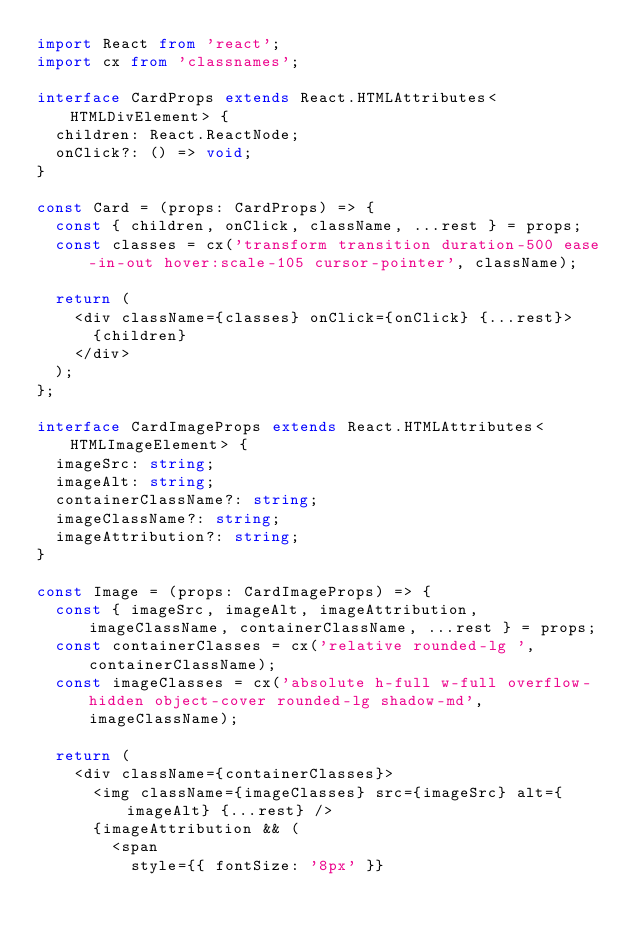<code> <loc_0><loc_0><loc_500><loc_500><_TypeScript_>import React from 'react';
import cx from 'classnames';

interface CardProps extends React.HTMLAttributes<HTMLDivElement> {
  children: React.ReactNode;
  onClick?: () => void;
}

const Card = (props: CardProps) => {
  const { children, onClick, className, ...rest } = props;
  const classes = cx('transform transition duration-500 ease-in-out hover:scale-105 cursor-pointer', className);

  return (
    <div className={classes} onClick={onClick} {...rest}>
      {children}
    </div>
  );
};

interface CardImageProps extends React.HTMLAttributes<HTMLImageElement> {
  imageSrc: string;
  imageAlt: string;
  containerClassName?: string;
  imageClassName?: string;
  imageAttribution?: string;
}

const Image = (props: CardImageProps) => {
  const { imageSrc, imageAlt, imageAttribution, imageClassName, containerClassName, ...rest } = props;
  const containerClasses = cx('relative rounded-lg ', containerClassName);
  const imageClasses = cx('absolute h-full w-full overflow-hidden object-cover rounded-lg shadow-md', imageClassName);

  return (
    <div className={containerClasses}>
      <img className={imageClasses} src={imageSrc} alt={imageAlt} {...rest} />
      {imageAttribution && (
        <span
          style={{ fontSize: '8px' }}</code> 